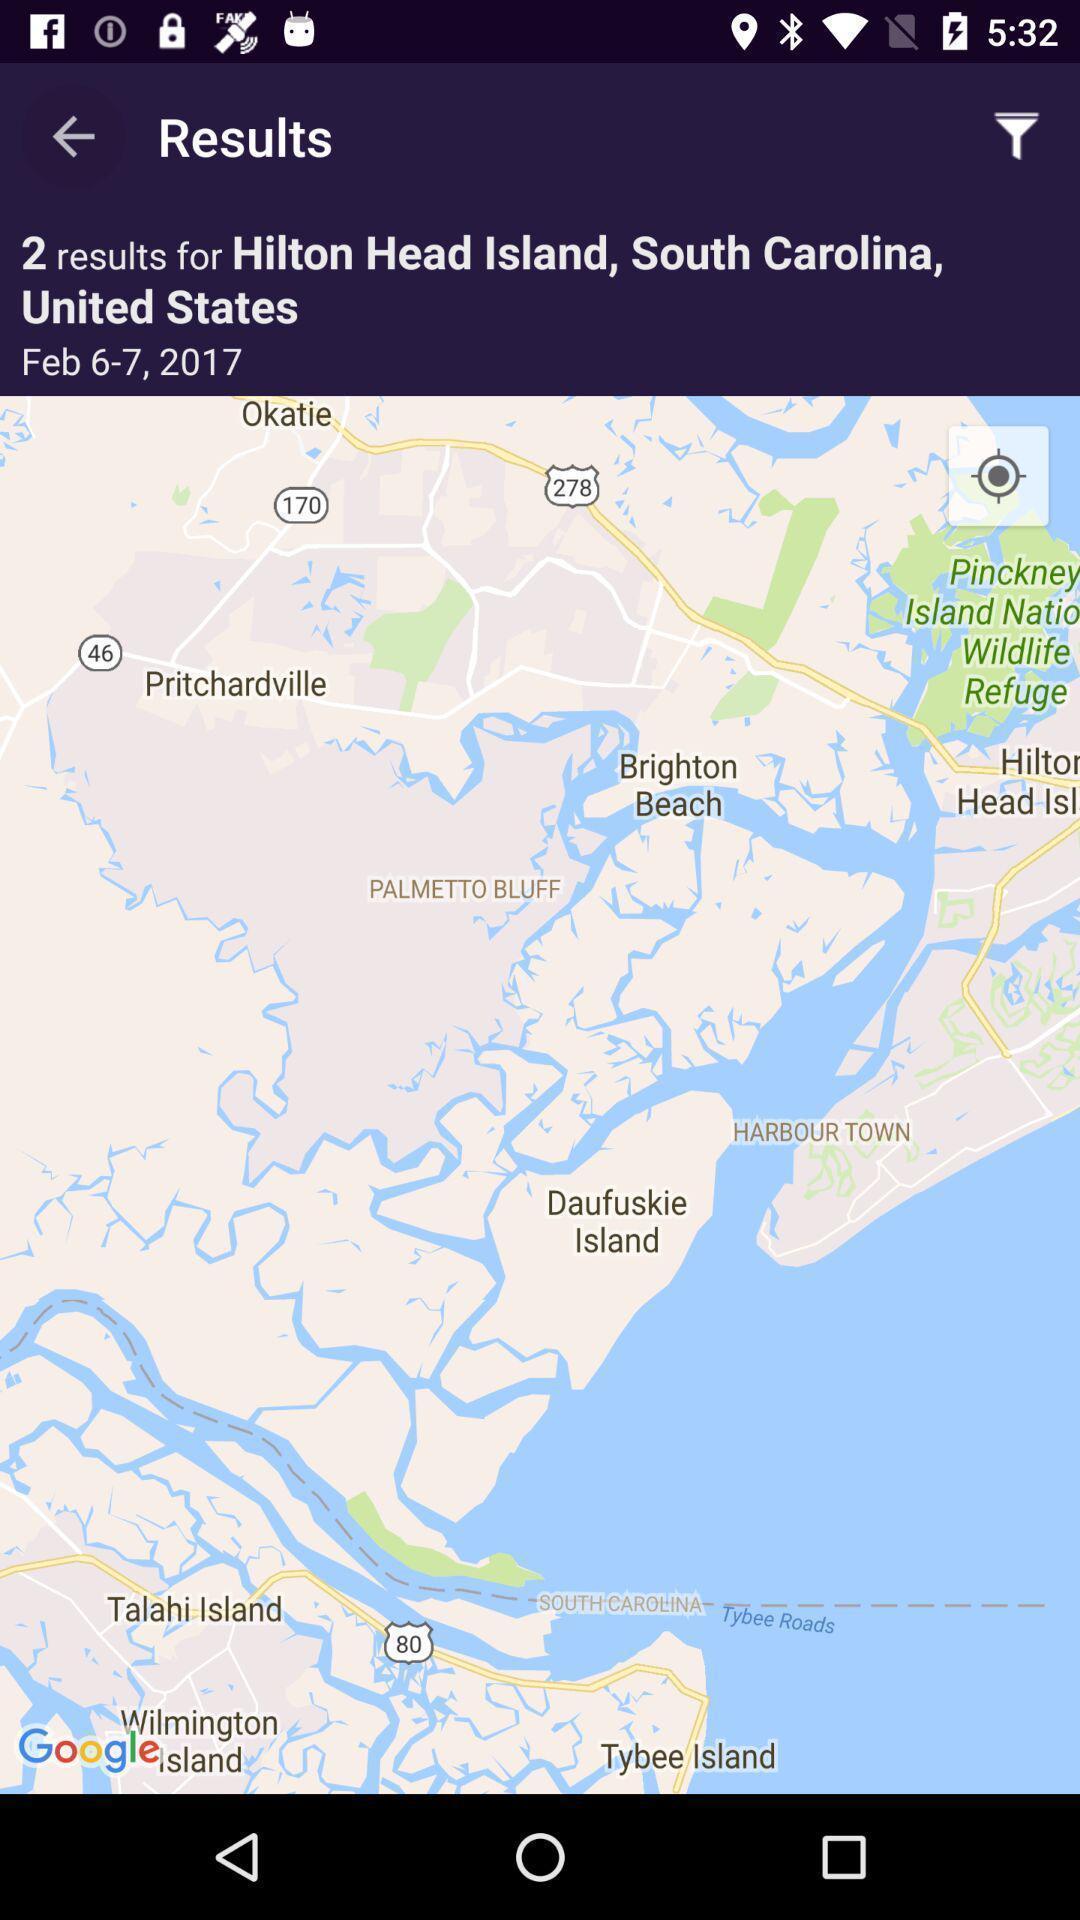Tell me about the visual elements in this screen capture. Page displaying results in navigator app. 